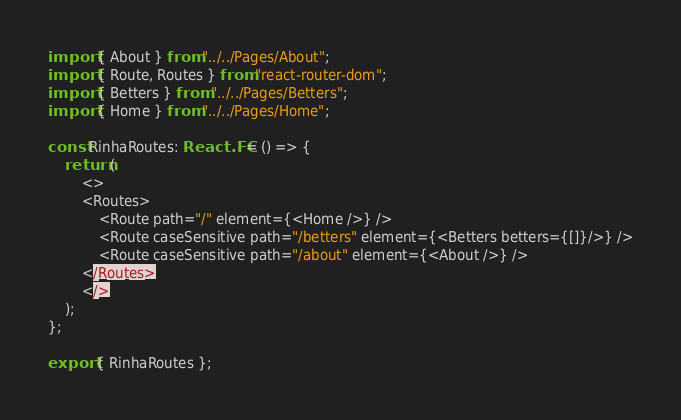<code> <loc_0><loc_0><loc_500><loc_500><_TypeScript_>import { About } from "../../Pages/About";
import { Route, Routes } from "react-router-dom";
import { Betters } from "../../Pages/Betters";
import { Home } from "../../Pages/Home";

const RinhaRoutes: React.FC = () => {
	return (
		<>
		<Routes>
			<Route path="/" element={<Home />} />
			<Route caseSensitive path="/betters" element={<Betters betters={[]}/>} />
			<Route caseSensitive path="/about" element={<About />} />
		</Routes>
		</>
	);
};

export { RinhaRoutes };
</code> 